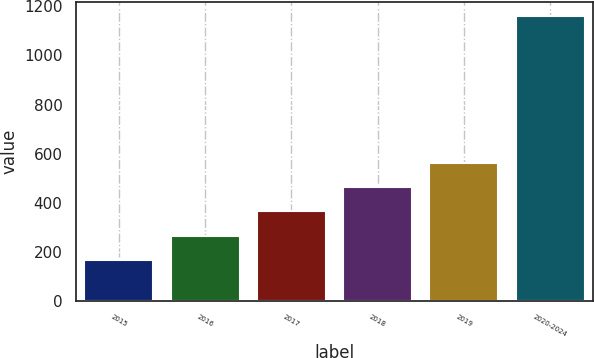<chart> <loc_0><loc_0><loc_500><loc_500><bar_chart><fcel>2015<fcel>2016<fcel>2017<fcel>2018<fcel>2019<fcel>2020-2024<nl><fcel>167<fcel>266.2<fcel>365.4<fcel>464.6<fcel>563.8<fcel>1159<nl></chart> 